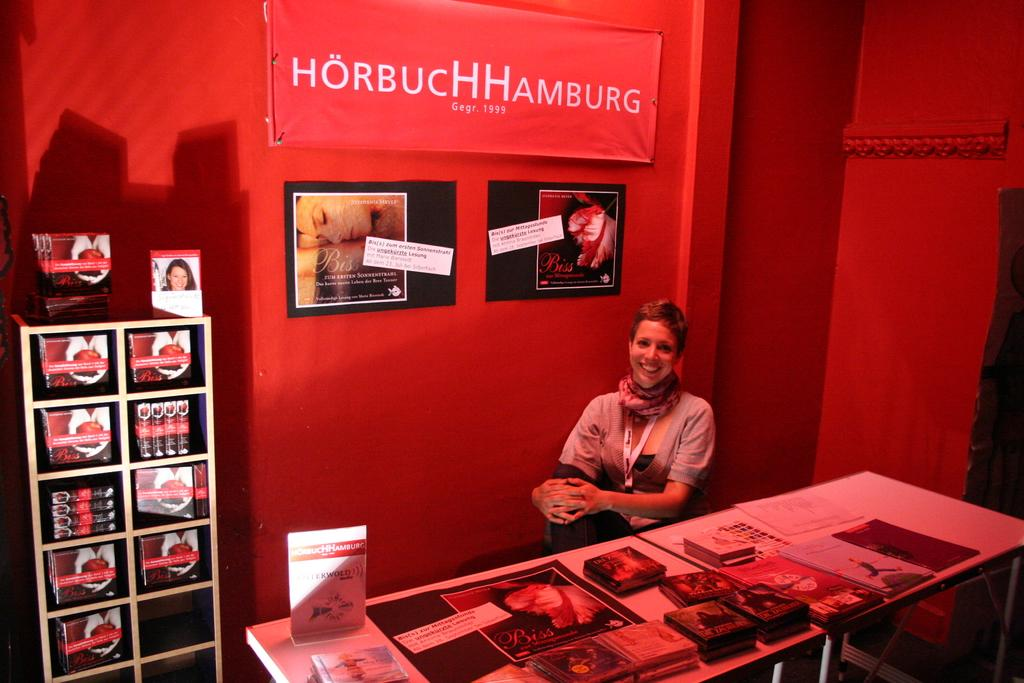Provide a one-sentence caption for the provided image. A smiling woman sits behind a table holding promotional materials and a sign saying HorbucHHHamburg behind her. 